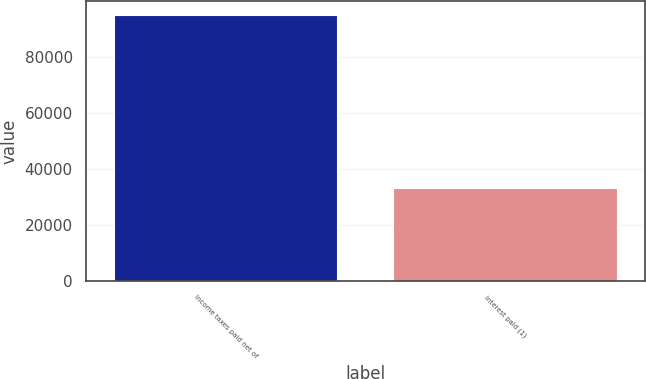<chart> <loc_0><loc_0><loc_500><loc_500><bar_chart><fcel>Income taxes paid net of<fcel>Interest paid (1)<nl><fcel>94938<fcel>33214<nl></chart> 